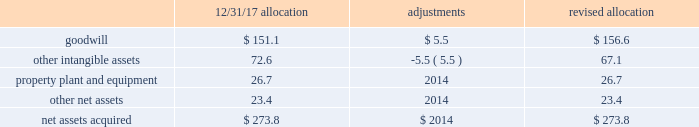Sacramento container acquisition in october 2017 , pca acquired substantially all of the assets of sacramento container corporation , and 100% ( 100 % ) of the membership interests of northern sheets , llc and central california sheets , llc ( collectively referred to as 201csacramento container 201d ) for a purchase price of $ 274 million , including working capital adjustments .
Funding for the acquisition came from available cash on hand .
Assets acquired include full-line corrugated products and sheet feeder operations in both mcclellan , california and kingsburg , california .
Sacramento container provides packaging solutions to customers serving portions of california 2019s strong agricultural market .
Sacramento container 2019s financial results are included in the packaging segment from the date of acquisition .
The company accounted for the sacramento container acquisition using the acquisition method of accounting in accordance with asc 805 , business combinations .
The total purchase price has been allocated to tangible and intangible assets acquired and liabilities assumed based on respective fair values , as follows ( dollars in millions ) : .
During the second quarter ended june 30 , 2018 , we made a $ 5.5 million net adjustment based on the final valuation of the intangible assets .
We recorded the adjustment as a decrease to other intangible assets with an offset to goodwill .
Goodwill is calculated as the excess of the purchase price over the fair value of the net assets acquired .
Among the factors that contributed to the recognition of goodwill were sacramento container 2019s commitment to continuous improvement and regional synergies , as well as the expected increases in pca 2019s containerboard integration levels .
Goodwill is deductible for tax purposes .
Other intangible assets , primarily customer relationships , were assigned an estimated weighted average useful life of 9.6 years .
Property , plant and equipment were assigned estimated useful lives ranging from one to 13 years. .
What percentage of the revised allocation of net assets acquired is property , plant and equipment? 
Computations: (26.7 / 273.8)
Answer: 0.09752. 